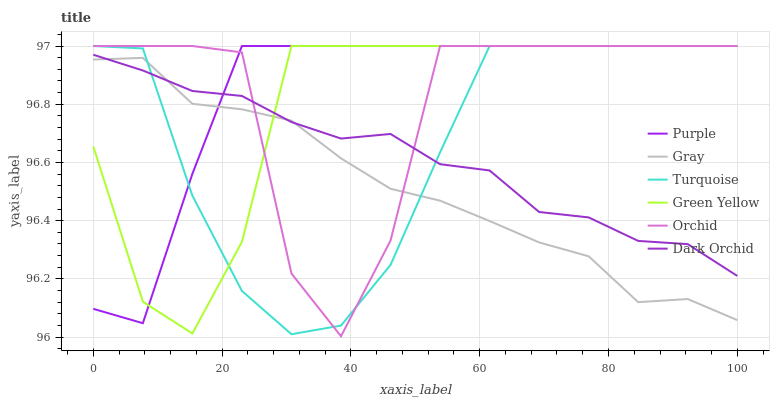Does Gray have the minimum area under the curve?
Answer yes or no. Yes. Does Purple have the maximum area under the curve?
Answer yes or no. Yes. Does Turquoise have the minimum area under the curve?
Answer yes or no. No. Does Turquoise have the maximum area under the curve?
Answer yes or no. No. Is Gray the smoothest?
Answer yes or no. Yes. Is Orchid the roughest?
Answer yes or no. Yes. Is Turquoise the smoothest?
Answer yes or no. No. Is Turquoise the roughest?
Answer yes or no. No. Does Orchid have the lowest value?
Answer yes or no. Yes. Does Turquoise have the lowest value?
Answer yes or no. No. Does Orchid have the highest value?
Answer yes or no. Yes. Does Dark Orchid have the highest value?
Answer yes or no. No. Does Green Yellow intersect Gray?
Answer yes or no. Yes. Is Green Yellow less than Gray?
Answer yes or no. No. Is Green Yellow greater than Gray?
Answer yes or no. No. 